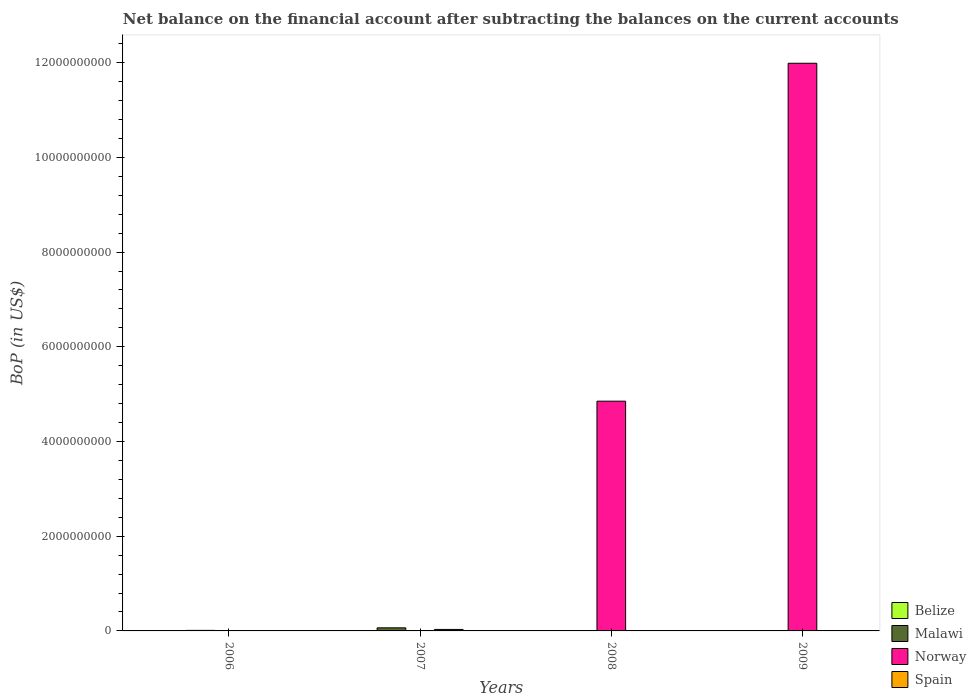In how many cases, is the number of bars for a given year not equal to the number of legend labels?
Give a very brief answer. 4. Across all years, what is the maximum Balance of Payments in Norway?
Your response must be concise. 1.20e+1. Across all years, what is the minimum Balance of Payments in Norway?
Your response must be concise. 0. In which year was the Balance of Payments in Norway maximum?
Offer a very short reply. 2009. What is the total Balance of Payments in Norway in the graph?
Keep it short and to the point. 1.68e+1. What is the difference between the Balance of Payments in Spain in 2008 and the Balance of Payments in Malawi in 2006?
Offer a very short reply. -1.14e+07. What is the average Balance of Payments in Spain per year?
Make the answer very short. 7.91e+06. What is the difference between the highest and the lowest Balance of Payments in Malawi?
Offer a very short reply. 6.53e+07. In how many years, is the Balance of Payments in Malawi greater than the average Balance of Payments in Malawi taken over all years?
Your response must be concise. 1. Is it the case that in every year, the sum of the Balance of Payments in Malawi and Balance of Payments in Spain is greater than the sum of Balance of Payments in Belize and Balance of Payments in Norway?
Ensure brevity in your answer.  No. Is it the case that in every year, the sum of the Balance of Payments in Spain and Balance of Payments in Malawi is greater than the Balance of Payments in Norway?
Your answer should be compact. No. Are all the bars in the graph horizontal?
Your response must be concise. No. How many years are there in the graph?
Provide a succinct answer. 4. What is the difference between two consecutive major ticks on the Y-axis?
Keep it short and to the point. 2.00e+09. Are the values on the major ticks of Y-axis written in scientific E-notation?
Ensure brevity in your answer.  No. Does the graph contain any zero values?
Your answer should be very brief. Yes. Where does the legend appear in the graph?
Give a very brief answer. Bottom right. How many legend labels are there?
Offer a very short reply. 4. How are the legend labels stacked?
Your answer should be compact. Vertical. What is the title of the graph?
Give a very brief answer. Net balance on the financial account after subtracting the balances on the current accounts. What is the label or title of the Y-axis?
Your answer should be compact. BoP (in US$). What is the BoP (in US$) of Belize in 2006?
Offer a terse response. 0. What is the BoP (in US$) in Malawi in 2006?
Provide a short and direct response. 1.14e+07. What is the BoP (in US$) in Belize in 2007?
Make the answer very short. 0. What is the BoP (in US$) of Malawi in 2007?
Your response must be concise. 6.53e+07. What is the BoP (in US$) in Spain in 2007?
Give a very brief answer. 3.16e+07. What is the BoP (in US$) of Belize in 2008?
Keep it short and to the point. 0. What is the BoP (in US$) in Norway in 2008?
Offer a terse response. 4.85e+09. What is the BoP (in US$) of Norway in 2009?
Your answer should be very brief. 1.20e+1. What is the BoP (in US$) of Spain in 2009?
Your response must be concise. 0. Across all years, what is the maximum BoP (in US$) of Malawi?
Offer a terse response. 6.53e+07. Across all years, what is the maximum BoP (in US$) in Norway?
Keep it short and to the point. 1.20e+1. Across all years, what is the maximum BoP (in US$) of Spain?
Your answer should be very brief. 3.16e+07. Across all years, what is the minimum BoP (in US$) of Malawi?
Your response must be concise. 0. Across all years, what is the minimum BoP (in US$) of Norway?
Give a very brief answer. 0. What is the total BoP (in US$) in Belize in the graph?
Give a very brief answer. 0. What is the total BoP (in US$) in Malawi in the graph?
Offer a very short reply. 7.67e+07. What is the total BoP (in US$) of Norway in the graph?
Make the answer very short. 1.68e+1. What is the total BoP (in US$) of Spain in the graph?
Make the answer very short. 3.16e+07. What is the difference between the BoP (in US$) in Malawi in 2006 and that in 2007?
Provide a short and direct response. -5.39e+07. What is the difference between the BoP (in US$) of Norway in 2008 and that in 2009?
Provide a succinct answer. -7.14e+09. What is the difference between the BoP (in US$) in Malawi in 2006 and the BoP (in US$) in Spain in 2007?
Your response must be concise. -2.02e+07. What is the difference between the BoP (in US$) in Malawi in 2006 and the BoP (in US$) in Norway in 2008?
Make the answer very short. -4.84e+09. What is the difference between the BoP (in US$) of Malawi in 2006 and the BoP (in US$) of Norway in 2009?
Your response must be concise. -1.20e+1. What is the difference between the BoP (in US$) of Malawi in 2007 and the BoP (in US$) of Norway in 2008?
Offer a very short reply. -4.79e+09. What is the difference between the BoP (in US$) in Malawi in 2007 and the BoP (in US$) in Norway in 2009?
Keep it short and to the point. -1.19e+1. What is the average BoP (in US$) of Malawi per year?
Your answer should be very brief. 1.92e+07. What is the average BoP (in US$) of Norway per year?
Provide a succinct answer. 4.21e+09. What is the average BoP (in US$) in Spain per year?
Your answer should be very brief. 7.91e+06. In the year 2007, what is the difference between the BoP (in US$) of Malawi and BoP (in US$) of Spain?
Your response must be concise. 3.37e+07. What is the ratio of the BoP (in US$) in Malawi in 2006 to that in 2007?
Provide a short and direct response. 0.17. What is the ratio of the BoP (in US$) in Norway in 2008 to that in 2009?
Keep it short and to the point. 0.4. What is the difference between the highest and the lowest BoP (in US$) in Malawi?
Keep it short and to the point. 6.53e+07. What is the difference between the highest and the lowest BoP (in US$) of Norway?
Keep it short and to the point. 1.20e+1. What is the difference between the highest and the lowest BoP (in US$) in Spain?
Offer a terse response. 3.16e+07. 